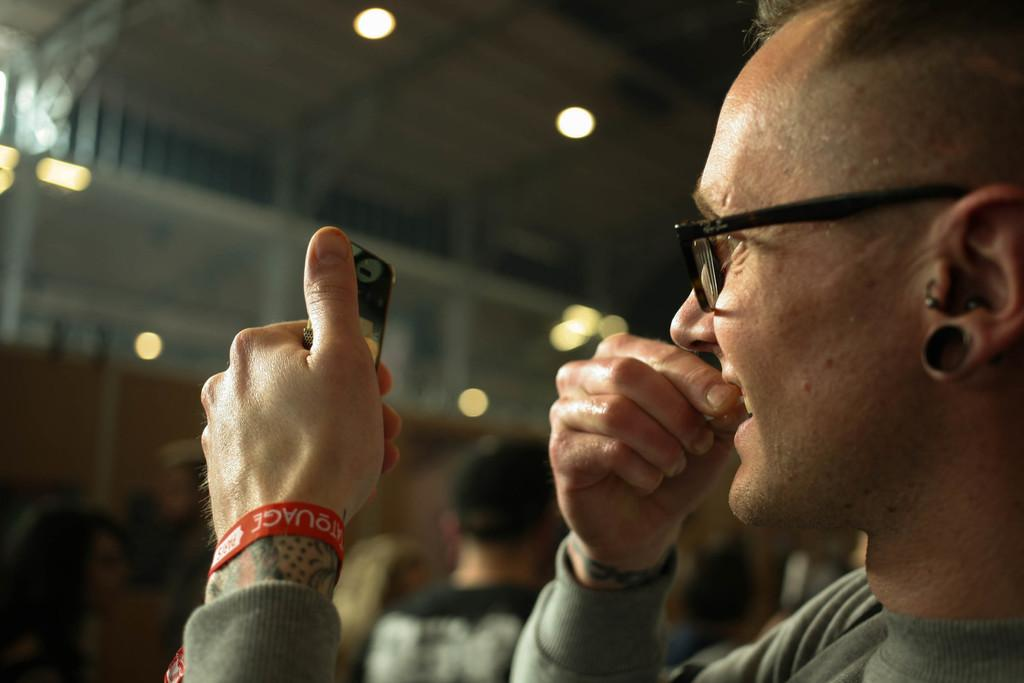What is the person on the left side of the image doing? The person is holding a cell phone. What can be seen above the person in the image? There are lights over the ceiling in the image. How many other persons are visible in the image? There are other persons visible in the image. Where was the image taken? The image was taken inside a building. What type of texture can be seen on the beast in the image? There is no beast present in the image, so it is not possible to determine the texture of its skin or fur. 